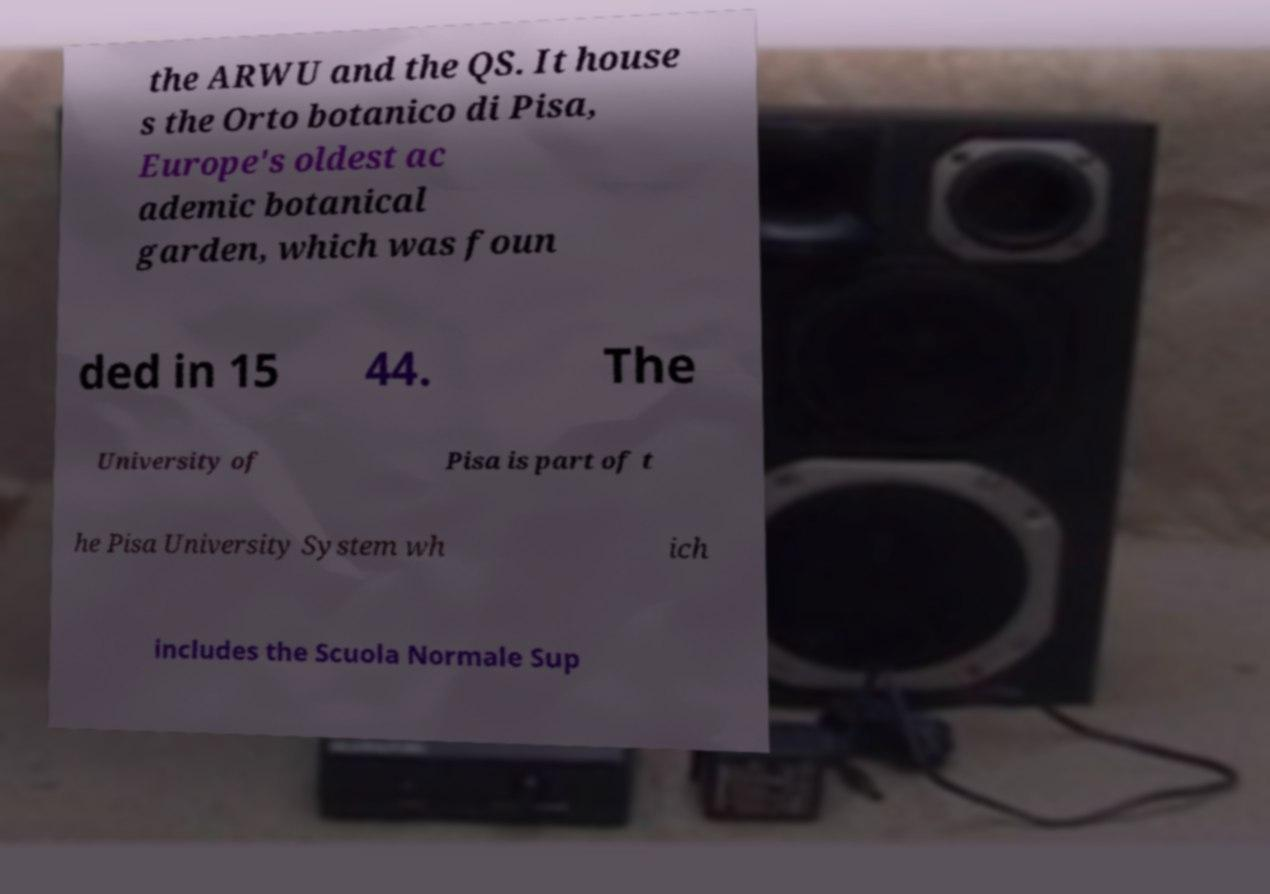Please identify and transcribe the text found in this image. the ARWU and the QS. It house s the Orto botanico di Pisa, Europe's oldest ac ademic botanical garden, which was foun ded in 15 44. The University of Pisa is part of t he Pisa University System wh ich includes the Scuola Normale Sup 